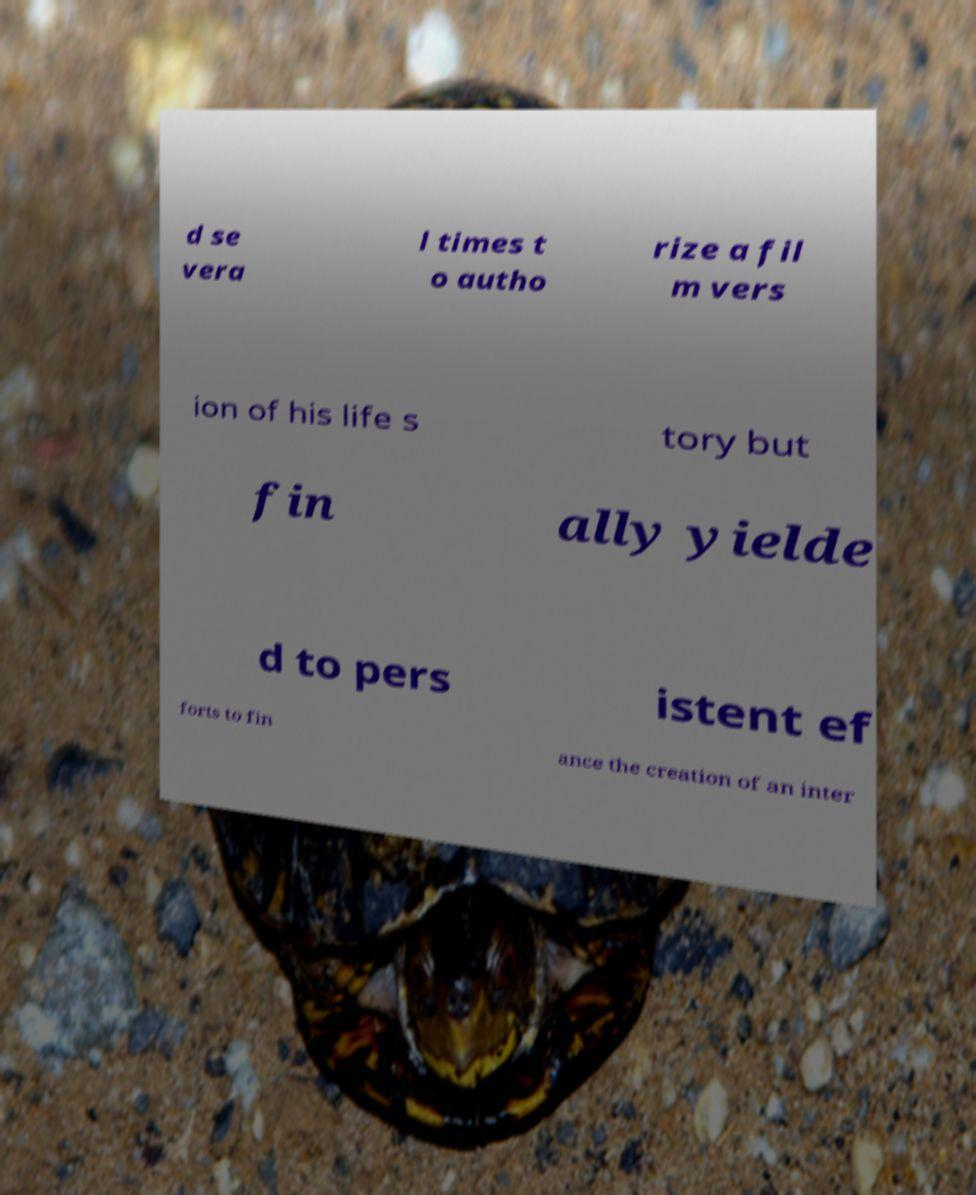Can you read and provide the text displayed in the image?This photo seems to have some interesting text. Can you extract and type it out for me? d se vera l times t o autho rize a fil m vers ion of his life s tory but fin ally yielde d to pers istent ef forts to fin ance the creation of an inter 